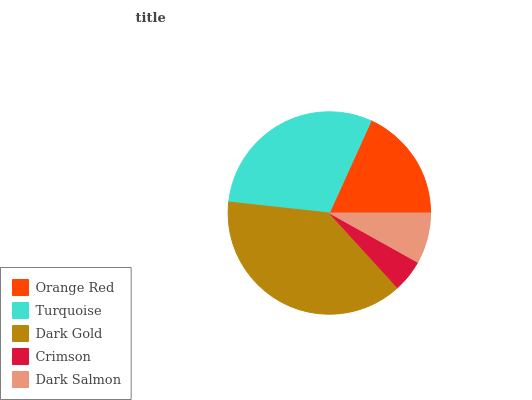Is Crimson the minimum?
Answer yes or no. Yes. Is Dark Gold the maximum?
Answer yes or no. Yes. Is Turquoise the minimum?
Answer yes or no. No. Is Turquoise the maximum?
Answer yes or no. No. Is Turquoise greater than Orange Red?
Answer yes or no. Yes. Is Orange Red less than Turquoise?
Answer yes or no. Yes. Is Orange Red greater than Turquoise?
Answer yes or no. No. Is Turquoise less than Orange Red?
Answer yes or no. No. Is Orange Red the high median?
Answer yes or no. Yes. Is Orange Red the low median?
Answer yes or no. Yes. Is Dark Gold the high median?
Answer yes or no. No. Is Dark Salmon the low median?
Answer yes or no. No. 